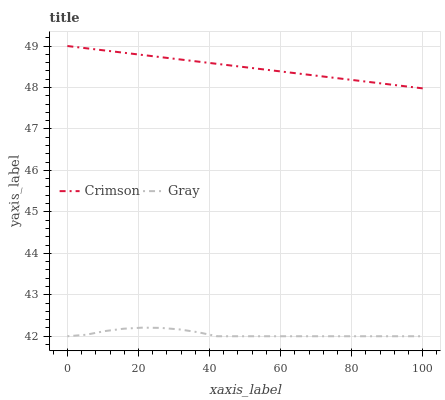Does Gray have the minimum area under the curve?
Answer yes or no. Yes. Does Crimson have the maximum area under the curve?
Answer yes or no. Yes. Does Gray have the maximum area under the curve?
Answer yes or no. No. Is Crimson the smoothest?
Answer yes or no. Yes. Is Gray the roughest?
Answer yes or no. Yes. Is Gray the smoothest?
Answer yes or no. No. Does Gray have the lowest value?
Answer yes or no. Yes. Does Crimson have the highest value?
Answer yes or no. Yes. Does Gray have the highest value?
Answer yes or no. No. Is Gray less than Crimson?
Answer yes or no. Yes. Is Crimson greater than Gray?
Answer yes or no. Yes. Does Gray intersect Crimson?
Answer yes or no. No. 